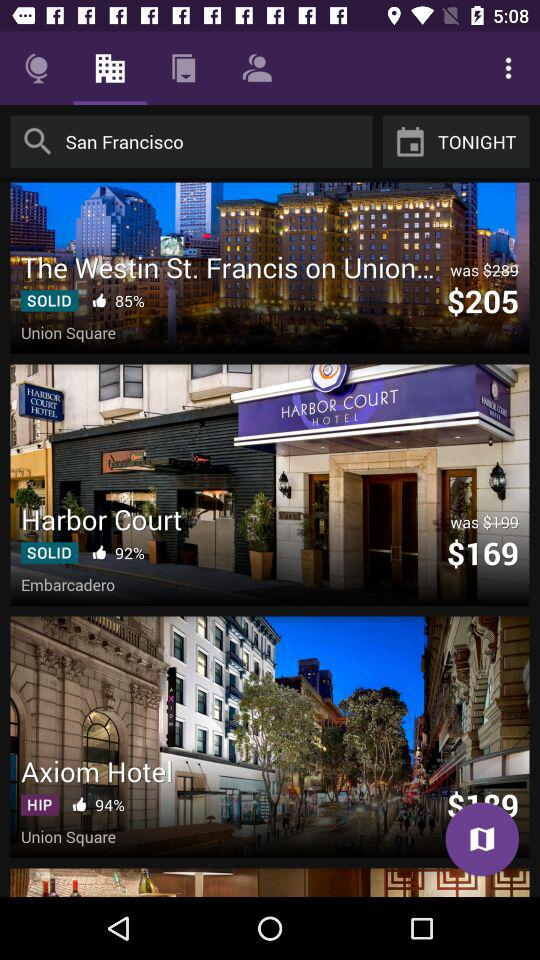What is the price of axiom hotel?
When the provided information is insufficient, respond with <no answer>. <no answer> 